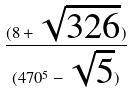<formula> <loc_0><loc_0><loc_500><loc_500>\frac { ( 8 + \sqrt { 3 2 6 } ) } { ( 4 7 0 ^ { 5 } - \sqrt { 5 } ) }</formula> 